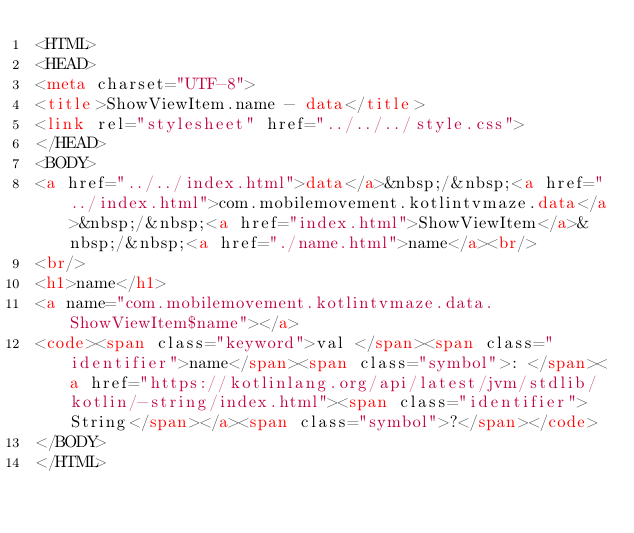<code> <loc_0><loc_0><loc_500><loc_500><_HTML_><HTML>
<HEAD>
<meta charset="UTF-8">
<title>ShowViewItem.name - data</title>
<link rel="stylesheet" href="../../../style.css">
</HEAD>
<BODY>
<a href="../../index.html">data</a>&nbsp;/&nbsp;<a href="../index.html">com.mobilemovement.kotlintvmaze.data</a>&nbsp;/&nbsp;<a href="index.html">ShowViewItem</a>&nbsp;/&nbsp;<a href="./name.html">name</a><br/>
<br/>
<h1>name</h1>
<a name="com.mobilemovement.kotlintvmaze.data.ShowViewItem$name"></a>
<code><span class="keyword">val </span><span class="identifier">name</span><span class="symbol">: </span><a href="https://kotlinlang.org/api/latest/jvm/stdlib/kotlin/-string/index.html"><span class="identifier">String</span></a><span class="symbol">?</span></code>
</BODY>
</HTML>
</code> 